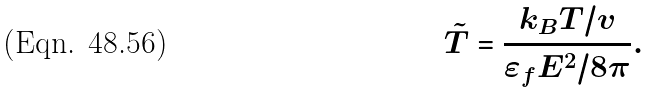<formula> <loc_0><loc_0><loc_500><loc_500>\tilde { T } = \frac { k _ { B } T / v } { \varepsilon _ { f } E ^ { 2 } / 8 \pi } .</formula> 